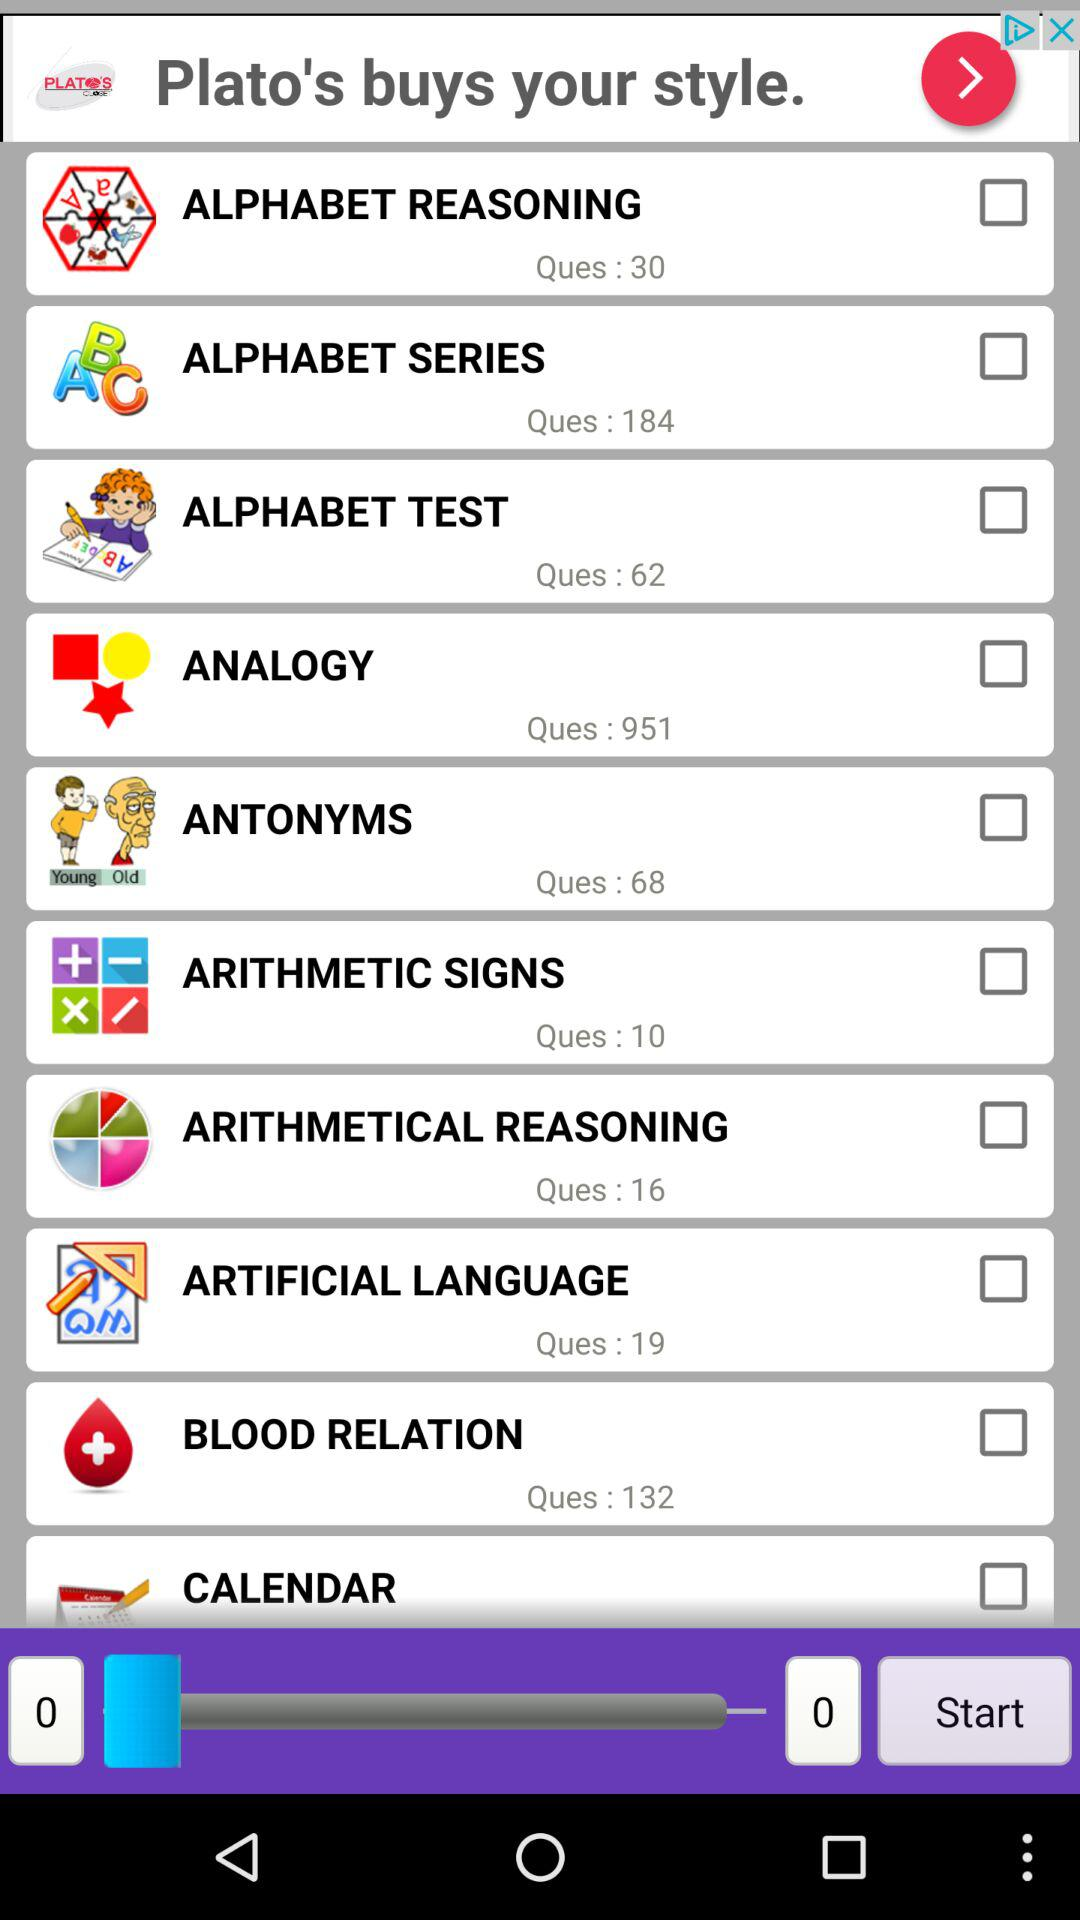How many questions of "ANALOGY" are there? There are 951 questions of "ANALOGY". 